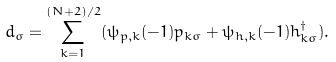<formula> <loc_0><loc_0><loc_500><loc_500>d _ { \sigma } = \sum _ { k = 1 } ^ { ( N + 2 ) / 2 } ( \psi _ { p , k } ( - 1 ) p _ { k \sigma } + \psi _ { h , k } ( - 1 ) h ^ { \dagger } _ { k \sigma } ) .</formula> 